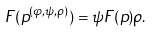<formula> <loc_0><loc_0><loc_500><loc_500>F ( p ^ { ( \varphi , \psi , \rho ) } ) = \psi F ( p ) \rho .</formula> 